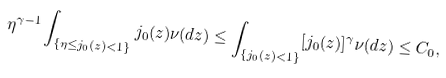<formula> <loc_0><loc_0><loc_500><loc_500>\eta ^ { \gamma - 1 } \int _ { \{ \eta \leq j _ { 0 } ( z ) < 1 \} } j _ { 0 } ( z ) \nu ( d z ) \leq \int _ { \{ j _ { 0 } ( z ) < 1 \} } [ j _ { 0 } ( z ) ] ^ { \gamma } \nu ( d z ) \leq C _ { 0 } ,</formula> 